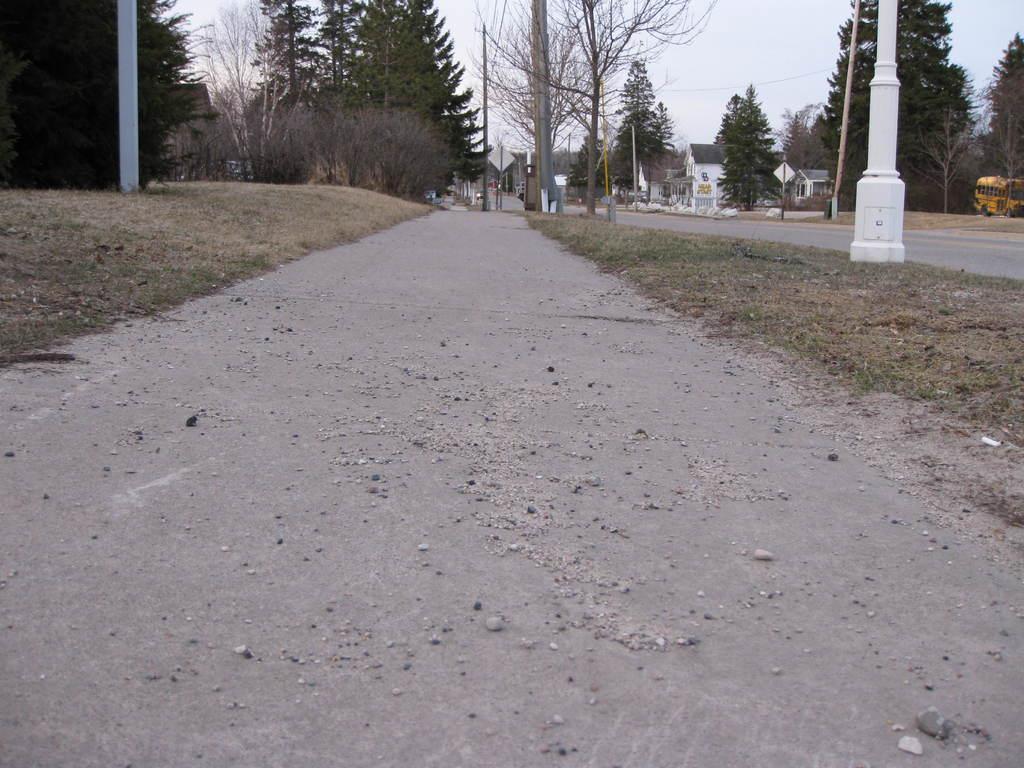How would you summarize this image in a sentence or two? In this image there is a road, few electric poles and cables, few buildings, two vehicles, grass and the sky. 